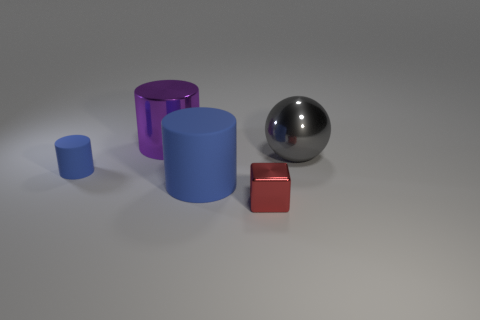Are there any large shiny objects?
Provide a short and direct response. Yes. There is a red block that is made of the same material as the purple cylinder; what size is it?
Give a very brief answer. Small. Is there a large rubber object that has the same color as the small matte cylinder?
Keep it short and to the point. Yes. There is a rubber thing that is in front of the small matte cylinder; is it the same color as the small cylinder behind the tiny cube?
Give a very brief answer. Yes. What is the size of the thing that is the same color as the tiny cylinder?
Keep it short and to the point. Large. Are there any large purple cylinders that have the same material as the purple object?
Ensure brevity in your answer.  No. What is the color of the metallic cylinder?
Offer a terse response. Purple. What is the size of the metallic object that is in front of the small object left of the metal object that is in front of the gray metal object?
Give a very brief answer. Small. How many other things are the same shape as the small red thing?
Keep it short and to the point. 0. There is a thing that is both in front of the tiny blue rubber object and behind the red cube; what color is it?
Provide a short and direct response. Blue. 